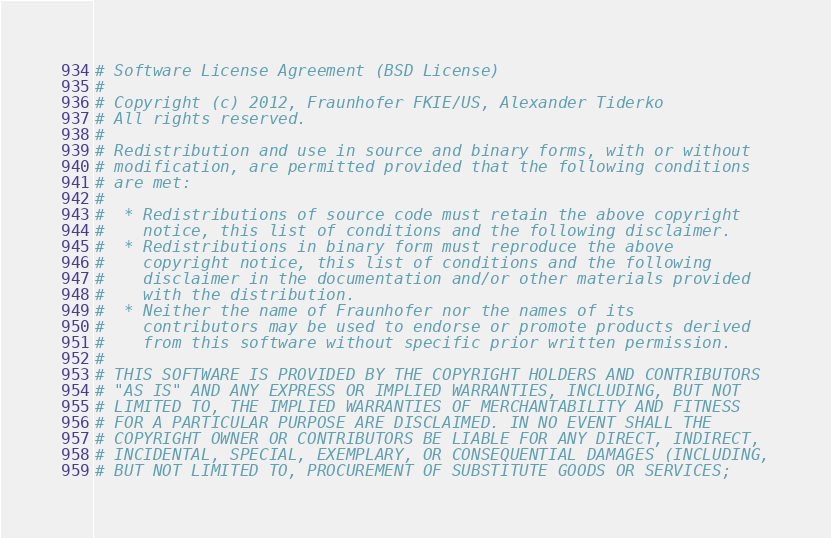Convert code to text. <code><loc_0><loc_0><loc_500><loc_500><_Python_># Software License Agreement (BSD License)
#
# Copyright (c) 2012, Fraunhofer FKIE/US, Alexander Tiderko
# All rights reserved.
#
# Redistribution and use in source and binary forms, with or without
# modification, are permitted provided that the following conditions
# are met:
#
#  * Redistributions of source code must retain the above copyright
#    notice, this list of conditions and the following disclaimer.
#  * Redistributions in binary form must reproduce the above
#    copyright notice, this list of conditions and the following
#    disclaimer in the documentation and/or other materials provided
#    with the distribution.
#  * Neither the name of Fraunhofer nor the names of its
#    contributors may be used to endorse or promote products derived
#    from this software without specific prior written permission.
#
# THIS SOFTWARE IS PROVIDED BY THE COPYRIGHT HOLDERS AND CONTRIBUTORS
# "AS IS" AND ANY EXPRESS OR IMPLIED WARRANTIES, INCLUDING, BUT NOT
# LIMITED TO, THE IMPLIED WARRANTIES OF MERCHANTABILITY AND FITNESS
# FOR A PARTICULAR PURPOSE ARE DISCLAIMED. IN NO EVENT SHALL THE
# COPYRIGHT OWNER OR CONTRIBUTORS BE LIABLE FOR ANY DIRECT, INDIRECT,
# INCIDENTAL, SPECIAL, EXEMPLARY, OR CONSEQUENTIAL DAMAGES (INCLUDING,
# BUT NOT LIMITED TO, PROCUREMENT OF SUBSTITUTE GOODS OR SERVICES;</code> 